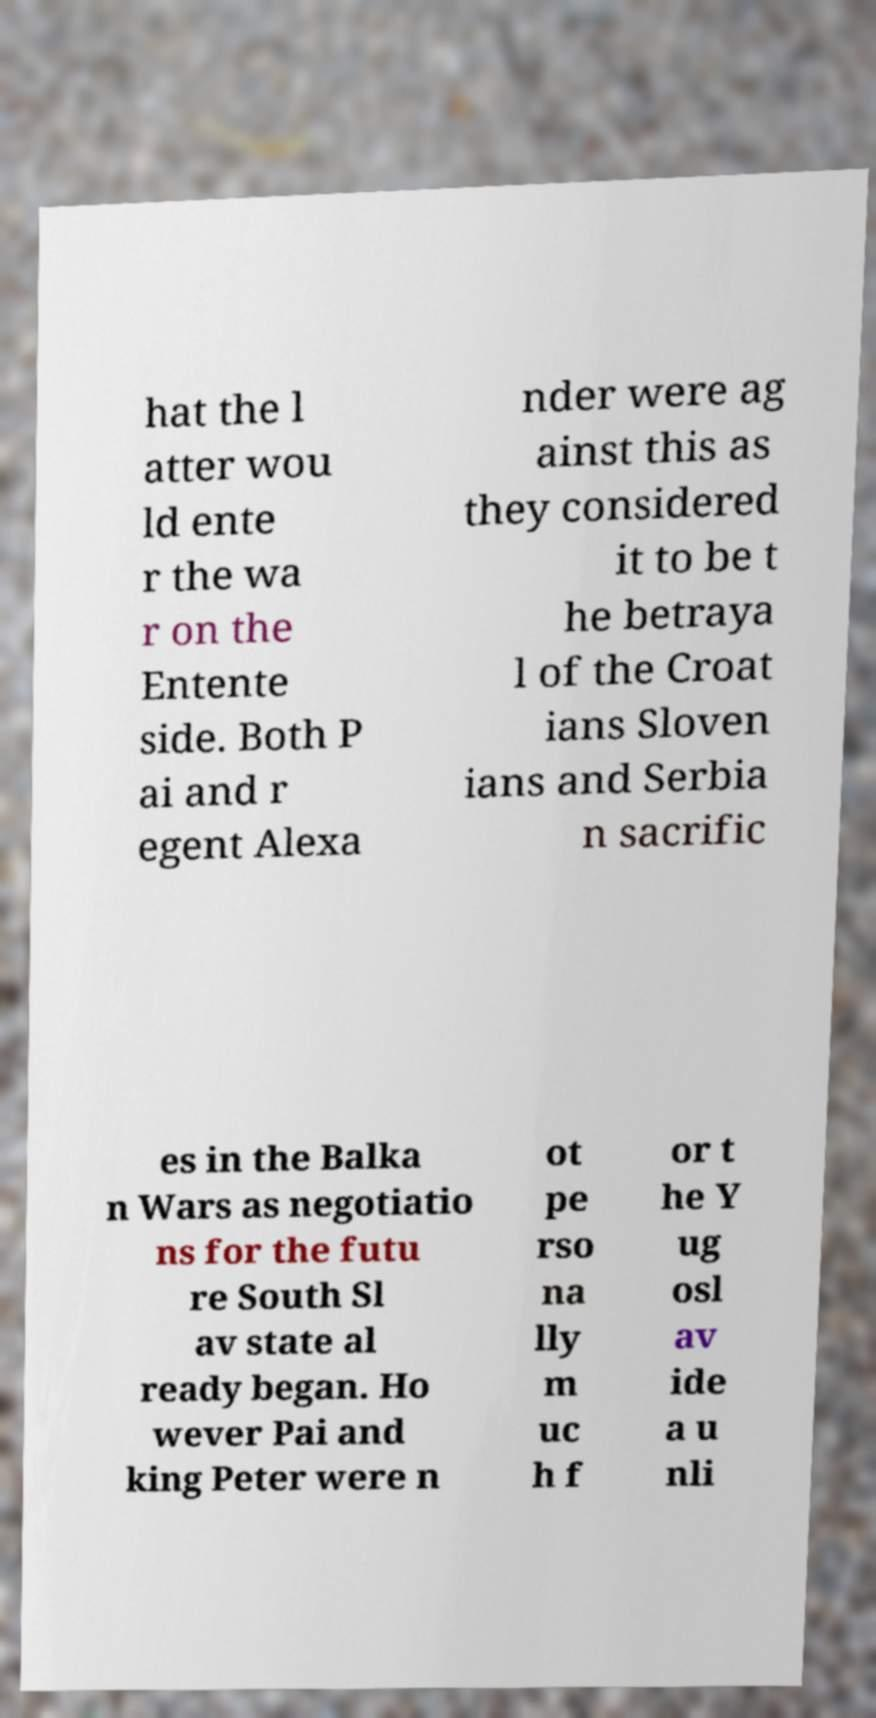Please identify and transcribe the text found in this image. hat the l atter wou ld ente r the wa r on the Entente side. Both P ai and r egent Alexa nder were ag ainst this as they considered it to be t he betraya l of the Croat ians Sloven ians and Serbia n sacrific es in the Balka n Wars as negotiatio ns for the futu re South Sl av state al ready began. Ho wever Pai and king Peter were n ot pe rso na lly m uc h f or t he Y ug osl av ide a u nli 